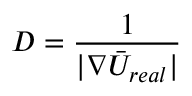<formula> <loc_0><loc_0><loc_500><loc_500>D = \frac { 1 } { | \nabla \bar { U } _ { r e a l } | }</formula> 